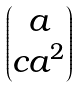<formula> <loc_0><loc_0><loc_500><loc_500>\begin{pmatrix} a \\ c a ^ { 2 } \end{pmatrix}</formula> 